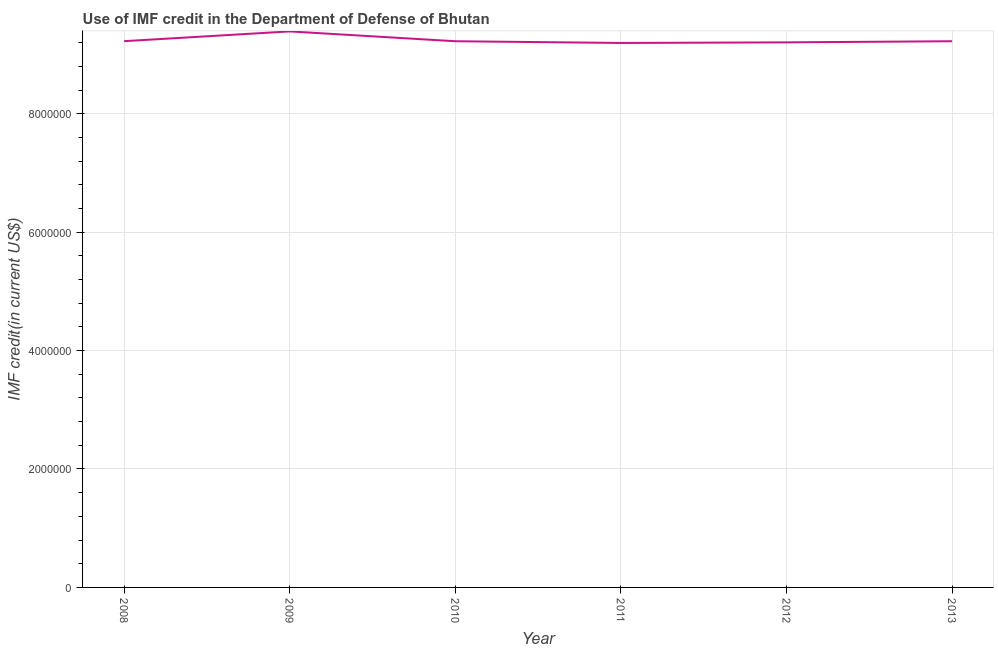What is the use of imf credit in dod in 2008?
Your answer should be very brief. 9.22e+06. Across all years, what is the maximum use of imf credit in dod?
Provide a short and direct response. 9.39e+06. Across all years, what is the minimum use of imf credit in dod?
Your response must be concise. 9.20e+06. In which year was the use of imf credit in dod minimum?
Your answer should be compact. 2011. What is the sum of the use of imf credit in dod?
Keep it short and to the point. 5.55e+07. What is the difference between the use of imf credit in dod in 2008 and 2011?
Your answer should be compact. 3.00e+04. What is the average use of imf credit in dod per year?
Offer a very short reply. 9.24e+06. What is the median use of imf credit in dod?
Ensure brevity in your answer.  9.22e+06. Do a majority of the years between 2013 and 2008 (inclusive) have use of imf credit in dod greater than 1200000 US$?
Your answer should be very brief. Yes. What is the ratio of the use of imf credit in dod in 2008 to that in 2013?
Provide a short and direct response. 1. Is the use of imf credit in dod in 2008 less than that in 2011?
Your answer should be very brief. No. Is the difference between the use of imf credit in dod in 2010 and 2012 greater than the difference between any two years?
Your answer should be compact. No. What is the difference between the highest and the second highest use of imf credit in dod?
Provide a short and direct response. 1.65e+05. What is the difference between the highest and the lowest use of imf credit in dod?
Provide a succinct answer. 1.95e+05. In how many years, is the use of imf credit in dod greater than the average use of imf credit in dod taken over all years?
Ensure brevity in your answer.  1. How many years are there in the graph?
Ensure brevity in your answer.  6. What is the difference between two consecutive major ticks on the Y-axis?
Your answer should be compact. 2.00e+06. Does the graph contain any zero values?
Your response must be concise. No. Does the graph contain grids?
Ensure brevity in your answer.  Yes. What is the title of the graph?
Give a very brief answer. Use of IMF credit in the Department of Defense of Bhutan. What is the label or title of the Y-axis?
Provide a succinct answer. IMF credit(in current US$). What is the IMF credit(in current US$) of 2008?
Provide a succinct answer. 9.22e+06. What is the IMF credit(in current US$) in 2009?
Offer a very short reply. 9.39e+06. What is the IMF credit(in current US$) in 2010?
Your answer should be compact. 9.22e+06. What is the IMF credit(in current US$) in 2011?
Provide a succinct answer. 9.20e+06. What is the IMF credit(in current US$) of 2012?
Provide a succinct answer. 9.20e+06. What is the IMF credit(in current US$) in 2013?
Provide a short and direct response. 9.22e+06. What is the difference between the IMF credit(in current US$) in 2008 and 2009?
Provide a succinct answer. -1.65e+05. What is the difference between the IMF credit(in current US$) in 2008 and 2011?
Offer a terse response. 3.00e+04. What is the difference between the IMF credit(in current US$) in 2008 and 2012?
Offer a very short reply. 2.00e+04. What is the difference between the IMF credit(in current US$) in 2009 and 2010?
Your answer should be compact. 1.66e+05. What is the difference between the IMF credit(in current US$) in 2009 and 2011?
Keep it short and to the point. 1.95e+05. What is the difference between the IMF credit(in current US$) in 2009 and 2012?
Give a very brief answer. 1.85e+05. What is the difference between the IMF credit(in current US$) in 2009 and 2013?
Ensure brevity in your answer.  1.66e+05. What is the difference between the IMF credit(in current US$) in 2010 and 2011?
Provide a short and direct response. 2.90e+04. What is the difference between the IMF credit(in current US$) in 2010 and 2012?
Provide a succinct answer. 1.90e+04. What is the difference between the IMF credit(in current US$) in 2011 and 2012?
Ensure brevity in your answer.  -10000. What is the difference between the IMF credit(in current US$) in 2011 and 2013?
Offer a very short reply. -2.90e+04. What is the difference between the IMF credit(in current US$) in 2012 and 2013?
Keep it short and to the point. -1.90e+04. What is the ratio of the IMF credit(in current US$) in 2008 to that in 2009?
Provide a succinct answer. 0.98. What is the ratio of the IMF credit(in current US$) in 2008 to that in 2010?
Give a very brief answer. 1. What is the ratio of the IMF credit(in current US$) in 2008 to that in 2013?
Offer a very short reply. 1. What is the ratio of the IMF credit(in current US$) in 2009 to that in 2010?
Give a very brief answer. 1.02. What is the ratio of the IMF credit(in current US$) in 2009 to that in 2013?
Keep it short and to the point. 1.02. What is the ratio of the IMF credit(in current US$) in 2010 to that in 2012?
Give a very brief answer. 1. What is the ratio of the IMF credit(in current US$) in 2010 to that in 2013?
Offer a very short reply. 1. What is the ratio of the IMF credit(in current US$) in 2011 to that in 2012?
Keep it short and to the point. 1. 